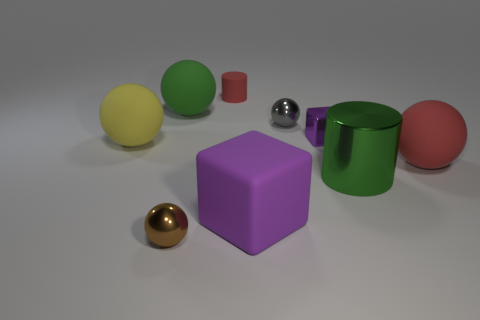Subtract all large green spheres. How many spheres are left? 4 Subtract 1 cylinders. How many cylinders are left? 1 Add 1 brown spheres. How many objects exist? 10 Subtract all yellow balls. How many balls are left? 4 Subtract 0 blue blocks. How many objects are left? 9 Subtract all cubes. How many objects are left? 7 Subtract all yellow blocks. Subtract all yellow cylinders. How many blocks are left? 2 Subtract all green blocks. How many red cylinders are left? 1 Subtract all tiny gray metallic objects. Subtract all small gray objects. How many objects are left? 7 Add 8 large purple cubes. How many large purple cubes are left? 9 